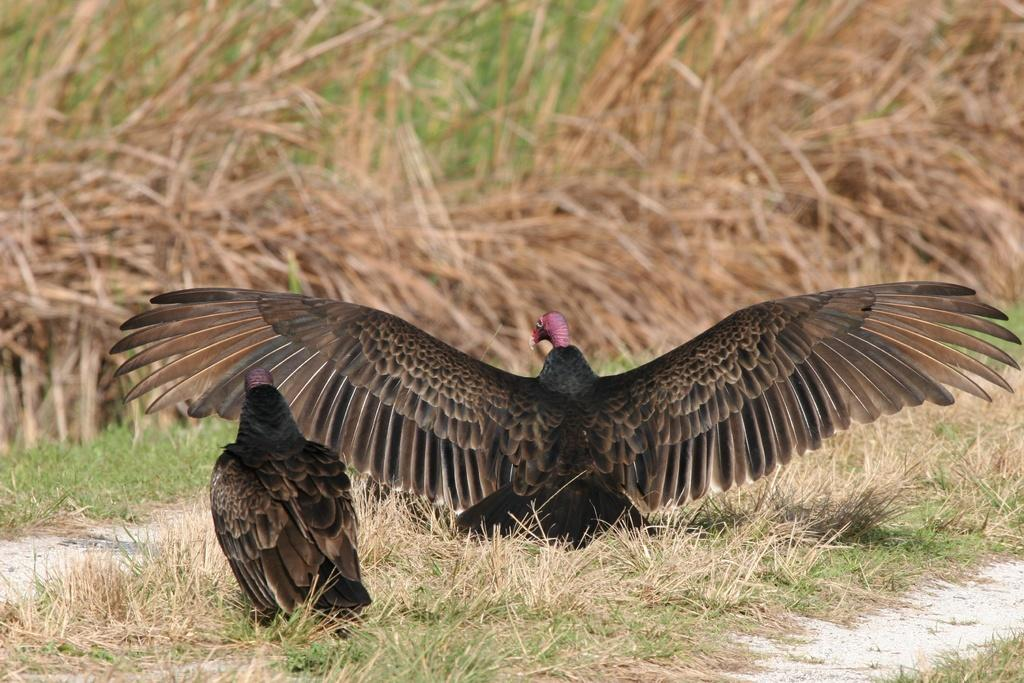What type of birds are in the image? There are two turkey vultures in the image. What features do the turkey vultures have? The turkey vultures have wings. What type of vegetation is visible in the image? There is dried grass visible in the image. What can be seen in the background of the image? In the background, there are dried plants. Where is the pail of coal located in the image? There is no pail of coal present in the image. How many oranges are visible in the image? There are no oranges visible in the image. 